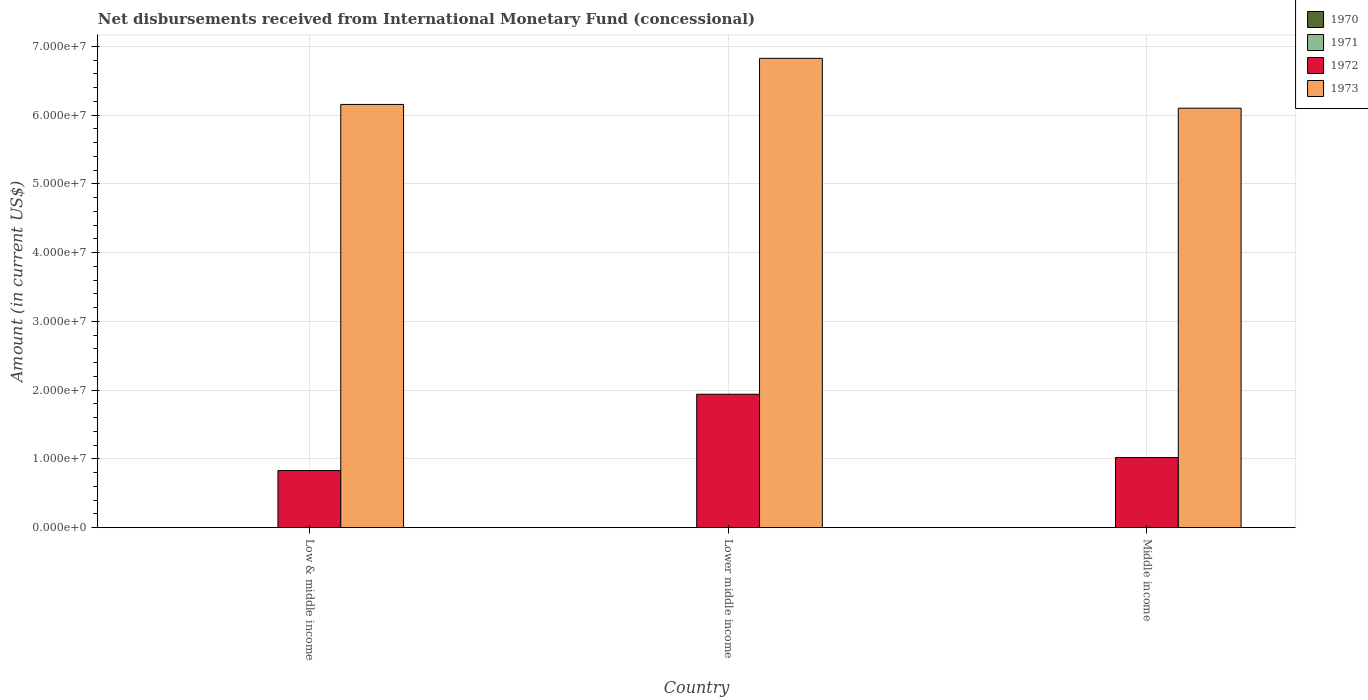How many bars are there on the 3rd tick from the left?
Your answer should be compact. 2. How many bars are there on the 3rd tick from the right?
Provide a short and direct response. 2. What is the label of the 3rd group of bars from the left?
Keep it short and to the point. Middle income. Across all countries, what is the maximum amount of disbursements received from International Monetary Fund in 1973?
Your response must be concise. 6.83e+07. Across all countries, what is the minimum amount of disbursements received from International Monetary Fund in 1973?
Make the answer very short. 6.10e+07. In which country was the amount of disbursements received from International Monetary Fund in 1972 maximum?
Offer a very short reply. Lower middle income. What is the total amount of disbursements received from International Monetary Fund in 1970 in the graph?
Give a very brief answer. 0. What is the difference between the amount of disbursements received from International Monetary Fund in 1972 in Lower middle income and that in Middle income?
Offer a very short reply. 9.21e+06. What is the difference between the amount of disbursements received from International Monetary Fund in 1971 in Middle income and the amount of disbursements received from International Monetary Fund in 1973 in Lower middle income?
Keep it short and to the point. -6.83e+07. What is the average amount of disbursements received from International Monetary Fund in 1971 per country?
Make the answer very short. 0. What is the difference between the amount of disbursements received from International Monetary Fund of/in 1973 and amount of disbursements received from International Monetary Fund of/in 1972 in Middle income?
Keep it short and to the point. 5.08e+07. What is the ratio of the amount of disbursements received from International Monetary Fund in 1972 in Low & middle income to that in Lower middle income?
Offer a terse response. 0.43. Is the amount of disbursements received from International Monetary Fund in 1973 in Low & middle income less than that in Middle income?
Ensure brevity in your answer.  No. Is the difference between the amount of disbursements received from International Monetary Fund in 1973 in Low & middle income and Middle income greater than the difference between the amount of disbursements received from International Monetary Fund in 1972 in Low & middle income and Middle income?
Your answer should be compact. Yes. What is the difference between the highest and the second highest amount of disbursements received from International Monetary Fund in 1972?
Provide a succinct answer. 9.21e+06. What is the difference between the highest and the lowest amount of disbursements received from International Monetary Fund in 1972?
Provide a short and direct response. 1.11e+07. Is the sum of the amount of disbursements received from International Monetary Fund in 1973 in Lower middle income and Middle income greater than the maximum amount of disbursements received from International Monetary Fund in 1972 across all countries?
Give a very brief answer. Yes. How many bars are there?
Your response must be concise. 6. Are all the bars in the graph horizontal?
Provide a succinct answer. No. What is the difference between two consecutive major ticks on the Y-axis?
Offer a terse response. 1.00e+07. Are the values on the major ticks of Y-axis written in scientific E-notation?
Your response must be concise. Yes. Does the graph contain any zero values?
Your answer should be compact. Yes. What is the title of the graph?
Give a very brief answer. Net disbursements received from International Monetary Fund (concessional). Does "1988" appear as one of the legend labels in the graph?
Provide a short and direct response. No. What is the label or title of the X-axis?
Offer a terse response. Country. What is the label or title of the Y-axis?
Your response must be concise. Amount (in current US$). What is the Amount (in current US$) in 1970 in Low & middle income?
Give a very brief answer. 0. What is the Amount (in current US$) of 1972 in Low & middle income?
Give a very brief answer. 8.30e+06. What is the Amount (in current US$) of 1973 in Low & middle income?
Offer a very short reply. 6.16e+07. What is the Amount (in current US$) of 1970 in Lower middle income?
Your response must be concise. 0. What is the Amount (in current US$) in 1972 in Lower middle income?
Ensure brevity in your answer.  1.94e+07. What is the Amount (in current US$) of 1973 in Lower middle income?
Ensure brevity in your answer.  6.83e+07. What is the Amount (in current US$) in 1970 in Middle income?
Provide a succinct answer. 0. What is the Amount (in current US$) in 1972 in Middle income?
Your response must be concise. 1.02e+07. What is the Amount (in current US$) in 1973 in Middle income?
Keep it short and to the point. 6.10e+07. Across all countries, what is the maximum Amount (in current US$) of 1972?
Your response must be concise. 1.94e+07. Across all countries, what is the maximum Amount (in current US$) of 1973?
Your answer should be compact. 6.83e+07. Across all countries, what is the minimum Amount (in current US$) of 1972?
Your answer should be compact. 8.30e+06. Across all countries, what is the minimum Amount (in current US$) in 1973?
Offer a terse response. 6.10e+07. What is the total Amount (in current US$) in 1971 in the graph?
Your answer should be compact. 0. What is the total Amount (in current US$) of 1972 in the graph?
Offer a terse response. 3.79e+07. What is the total Amount (in current US$) in 1973 in the graph?
Your answer should be very brief. 1.91e+08. What is the difference between the Amount (in current US$) of 1972 in Low & middle income and that in Lower middle income?
Offer a very short reply. -1.11e+07. What is the difference between the Amount (in current US$) of 1973 in Low & middle income and that in Lower middle income?
Give a very brief answer. -6.70e+06. What is the difference between the Amount (in current US$) of 1972 in Low & middle income and that in Middle income?
Give a very brief answer. -1.90e+06. What is the difference between the Amount (in current US$) of 1973 in Low & middle income and that in Middle income?
Offer a very short reply. 5.46e+05. What is the difference between the Amount (in current US$) in 1972 in Lower middle income and that in Middle income?
Keep it short and to the point. 9.21e+06. What is the difference between the Amount (in current US$) of 1973 in Lower middle income and that in Middle income?
Your response must be concise. 7.25e+06. What is the difference between the Amount (in current US$) in 1972 in Low & middle income and the Amount (in current US$) in 1973 in Lower middle income?
Provide a short and direct response. -6.00e+07. What is the difference between the Amount (in current US$) in 1972 in Low & middle income and the Amount (in current US$) in 1973 in Middle income?
Give a very brief answer. -5.27e+07. What is the difference between the Amount (in current US$) in 1972 in Lower middle income and the Amount (in current US$) in 1973 in Middle income?
Provide a short and direct response. -4.16e+07. What is the average Amount (in current US$) in 1970 per country?
Offer a very short reply. 0. What is the average Amount (in current US$) of 1972 per country?
Make the answer very short. 1.26e+07. What is the average Amount (in current US$) in 1973 per country?
Make the answer very short. 6.36e+07. What is the difference between the Amount (in current US$) in 1972 and Amount (in current US$) in 1973 in Low & middle income?
Offer a very short reply. -5.33e+07. What is the difference between the Amount (in current US$) in 1972 and Amount (in current US$) in 1973 in Lower middle income?
Offer a very short reply. -4.89e+07. What is the difference between the Amount (in current US$) of 1972 and Amount (in current US$) of 1973 in Middle income?
Provide a short and direct response. -5.08e+07. What is the ratio of the Amount (in current US$) in 1972 in Low & middle income to that in Lower middle income?
Provide a succinct answer. 0.43. What is the ratio of the Amount (in current US$) of 1973 in Low & middle income to that in Lower middle income?
Your response must be concise. 0.9. What is the ratio of the Amount (in current US$) in 1972 in Low & middle income to that in Middle income?
Provide a short and direct response. 0.81. What is the ratio of the Amount (in current US$) of 1973 in Low & middle income to that in Middle income?
Keep it short and to the point. 1.01. What is the ratio of the Amount (in current US$) of 1972 in Lower middle income to that in Middle income?
Make the answer very short. 1.9. What is the ratio of the Amount (in current US$) in 1973 in Lower middle income to that in Middle income?
Provide a short and direct response. 1.12. What is the difference between the highest and the second highest Amount (in current US$) of 1972?
Make the answer very short. 9.21e+06. What is the difference between the highest and the second highest Amount (in current US$) of 1973?
Make the answer very short. 6.70e+06. What is the difference between the highest and the lowest Amount (in current US$) in 1972?
Offer a terse response. 1.11e+07. What is the difference between the highest and the lowest Amount (in current US$) of 1973?
Your response must be concise. 7.25e+06. 